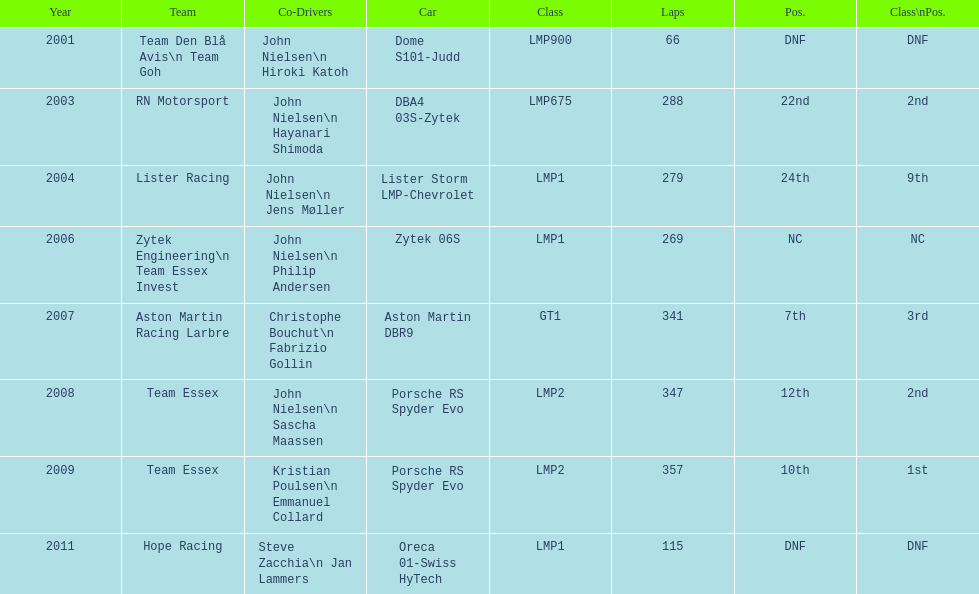How many times was the final position above 20? 2. 